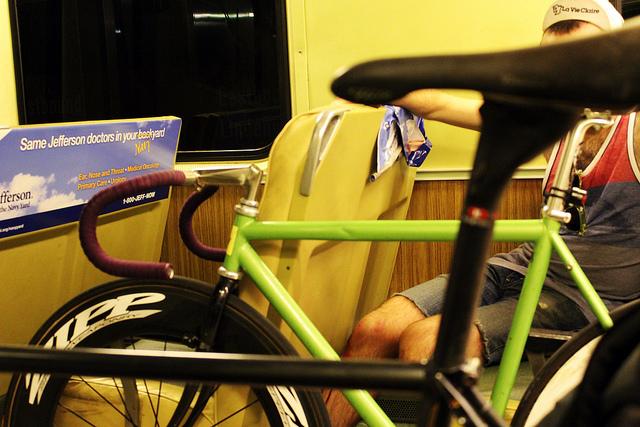Is the person riding the bike?
Give a very brief answer. No. How many green bikes are there?
Short answer required. 1. What color is this bicycle?
Be succinct. Green. What are the first two words, written in white, on the "blue sky"?
Short answer required. Same jefferson. 